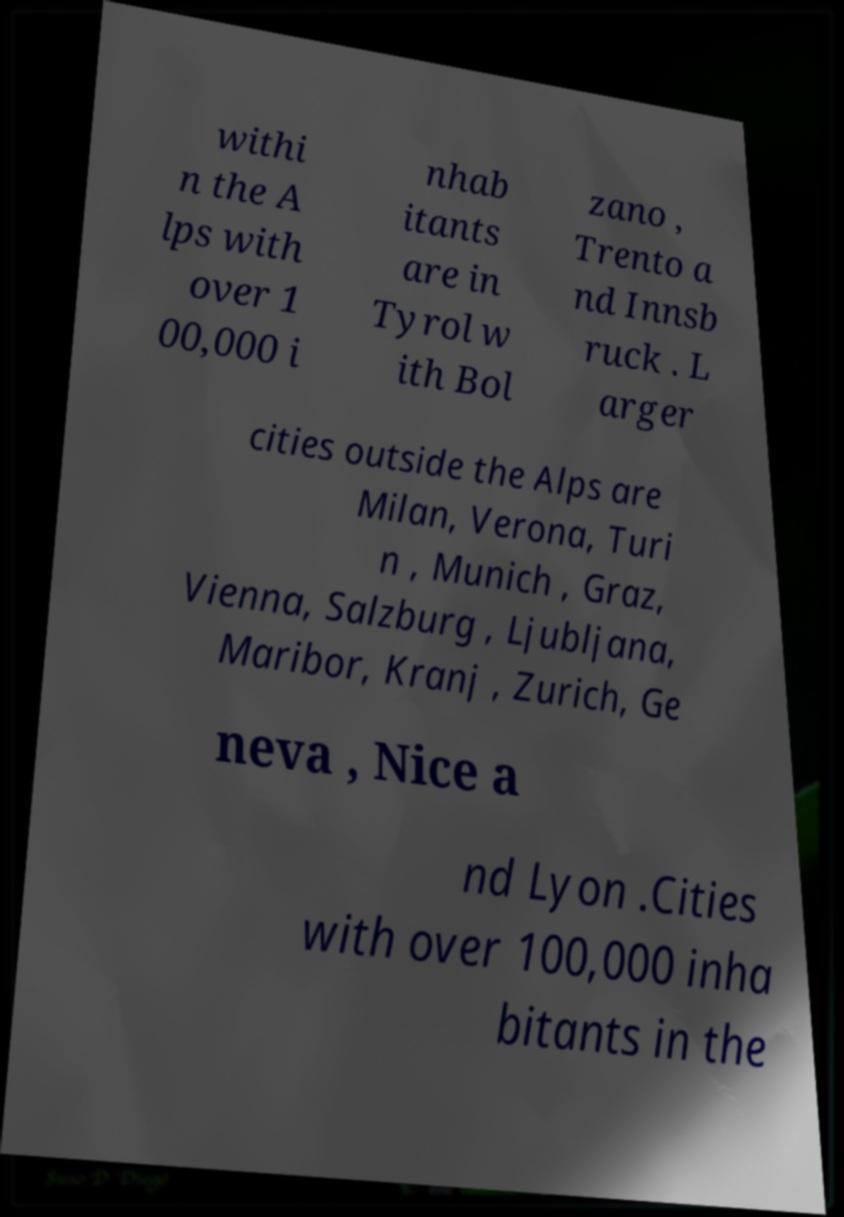I need the written content from this picture converted into text. Can you do that? withi n the A lps with over 1 00,000 i nhab itants are in Tyrol w ith Bol zano , Trento a nd Innsb ruck . L arger cities outside the Alps are Milan, Verona, Turi n , Munich , Graz, Vienna, Salzburg , Ljubljana, Maribor, Kranj , Zurich, Ge neva , Nice a nd Lyon .Cities with over 100,000 inha bitants in the 